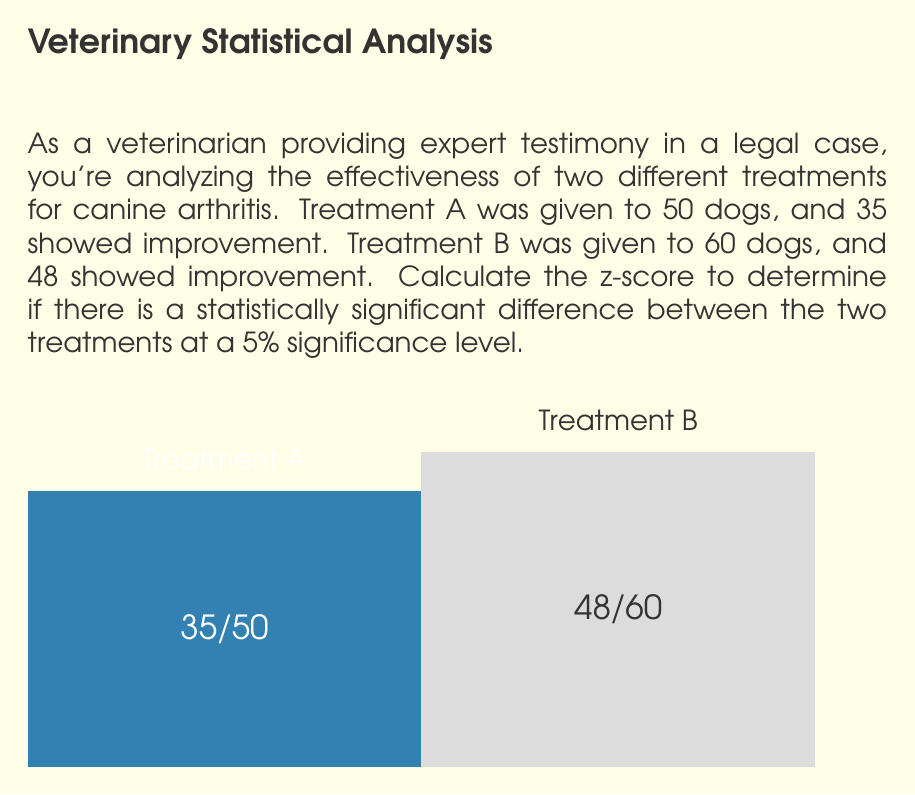Can you answer this question? To determine if there's a statistically significant difference between the two treatments, we'll use a two-proportion z-test. We'll follow these steps:

1) Calculate the pooled sample proportion:
   $$\hat{p} = \frac{X_1 + X_2}{n_1 + n_2} = \frac{35 + 48}{50 + 60} = \frac{83}{110} = 0.7545$$

2) Calculate the standard error:
   $$SE = \sqrt{\hat{p}(1-\hat{p})(\frac{1}{n_1} + \frac{1}{n_2})}$$
   $$SE = \sqrt{0.7545(1-0.7545)(\frac{1}{50} + \frac{1}{60})} = 0.0812$$

3) Calculate the z-score:
   $$z = \frac{(\hat{p}_1 - \hat{p}_2)}{\sqrt{\hat{p}(1-\hat{p})(\frac{1}{n_1} + \frac{1}{n_2})}}$$
   $$z = \frac{(\frac{35}{50} - \frac{48}{60})}{0.0812} = \frac{0.7 - 0.8}{0.0812} = -1.2315$$

4) Determine the critical z-value for a two-tailed test at 5% significance level:
   The critical z-value is ±1.96.

5) Compare the calculated z-score to the critical value:
   |-1.2315| < 1.96

Since the absolute value of our calculated z-score is less than the critical value, we fail to reject the null hypothesis at the 5% significance level.
Answer: z = -1.2315; Not statistically significant at 5% level 